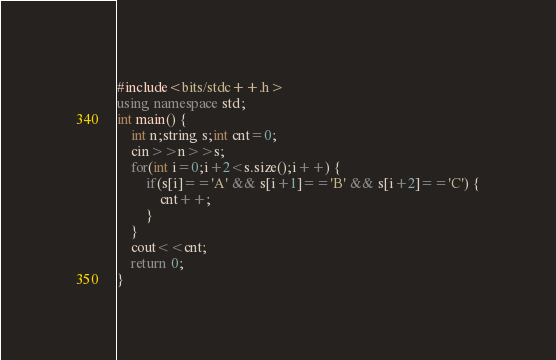Convert code to text. <code><loc_0><loc_0><loc_500><loc_500><_C++_>#include<bits/stdc++.h>
using namespace std;
int main() {
	int n;string s;int cnt=0;
	cin>>n>>s;
	for(int i=0;i+2<s.size();i++) {
		if(s[i]=='A' && s[i+1]=='B' && s[i+2]=='C') {
			cnt++;
		}
	} 
	cout<<cnt;
	return 0;
} </code> 